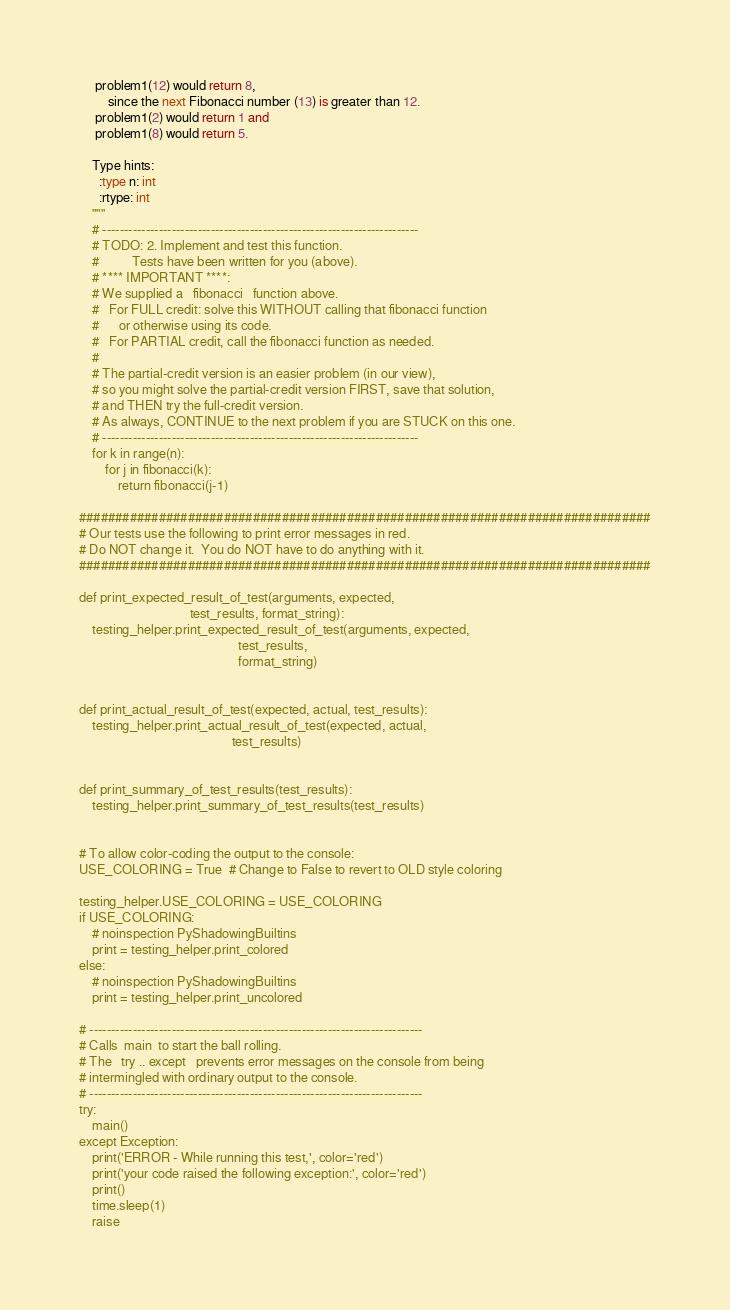Convert code to text. <code><loc_0><loc_0><loc_500><loc_500><_Python_>     problem1(12) would return 8,
         since the next Fibonacci number (13) is greater than 12.
     problem1(2) would return 1 and
     problem1(8) would return 5.

    Type hints:
      :type n: int
      :rtype: int
    """
    # -------------------------------------------------------------------------
    # TODO: 2. Implement and test this function.
    #          Tests have been written for you (above).
    # **** IMPORTANT ****:
    # We supplied a   fibonacci   function above.
    #   For FULL credit: solve this WITHOUT calling that fibonacci function
    #      or otherwise using its code.
    #   For PARTIAL credit, call the fibonacci function as needed.
    #
    # The partial-credit version is an easier problem (in our view),
    # so you might solve the partial-credit version FIRST, save that solution,
    # and THEN try the full-credit version.
    # As always, CONTINUE to the next problem if you are STUCK on this one.
    # -------------------------------------------------------------------------
    for k in range(n):
        for j in fibonacci(k):
            return fibonacci(j-1)

###############################################################################
# Our tests use the following to print error messages in red.
# Do NOT change it.  You do NOT have to do anything with it.
###############################################################################

def print_expected_result_of_test(arguments, expected,
                                  test_results, format_string):
    testing_helper.print_expected_result_of_test(arguments, expected,
                                                 test_results,
                                                 format_string)


def print_actual_result_of_test(expected, actual, test_results):
    testing_helper.print_actual_result_of_test(expected, actual,
                                               test_results)


def print_summary_of_test_results(test_results):
    testing_helper.print_summary_of_test_results(test_results)


# To allow color-coding the output to the console:
USE_COLORING = True  # Change to False to revert to OLD style coloring

testing_helper.USE_COLORING = USE_COLORING
if USE_COLORING:
    # noinspection PyShadowingBuiltins
    print = testing_helper.print_colored
else:
    # noinspection PyShadowingBuiltins
    print = testing_helper.print_uncolored

# -----------------------------------------------------------------------------
# Calls  main  to start the ball rolling.
# The   try .. except   prevents error messages on the console from being
# intermingled with ordinary output to the console.
# -----------------------------------------------------------------------------
try:
    main()
except Exception:
    print('ERROR - While running this test,', color='red')
    print('your code raised the following exception:', color='red')
    print()
    time.sleep(1)
    raise
</code> 